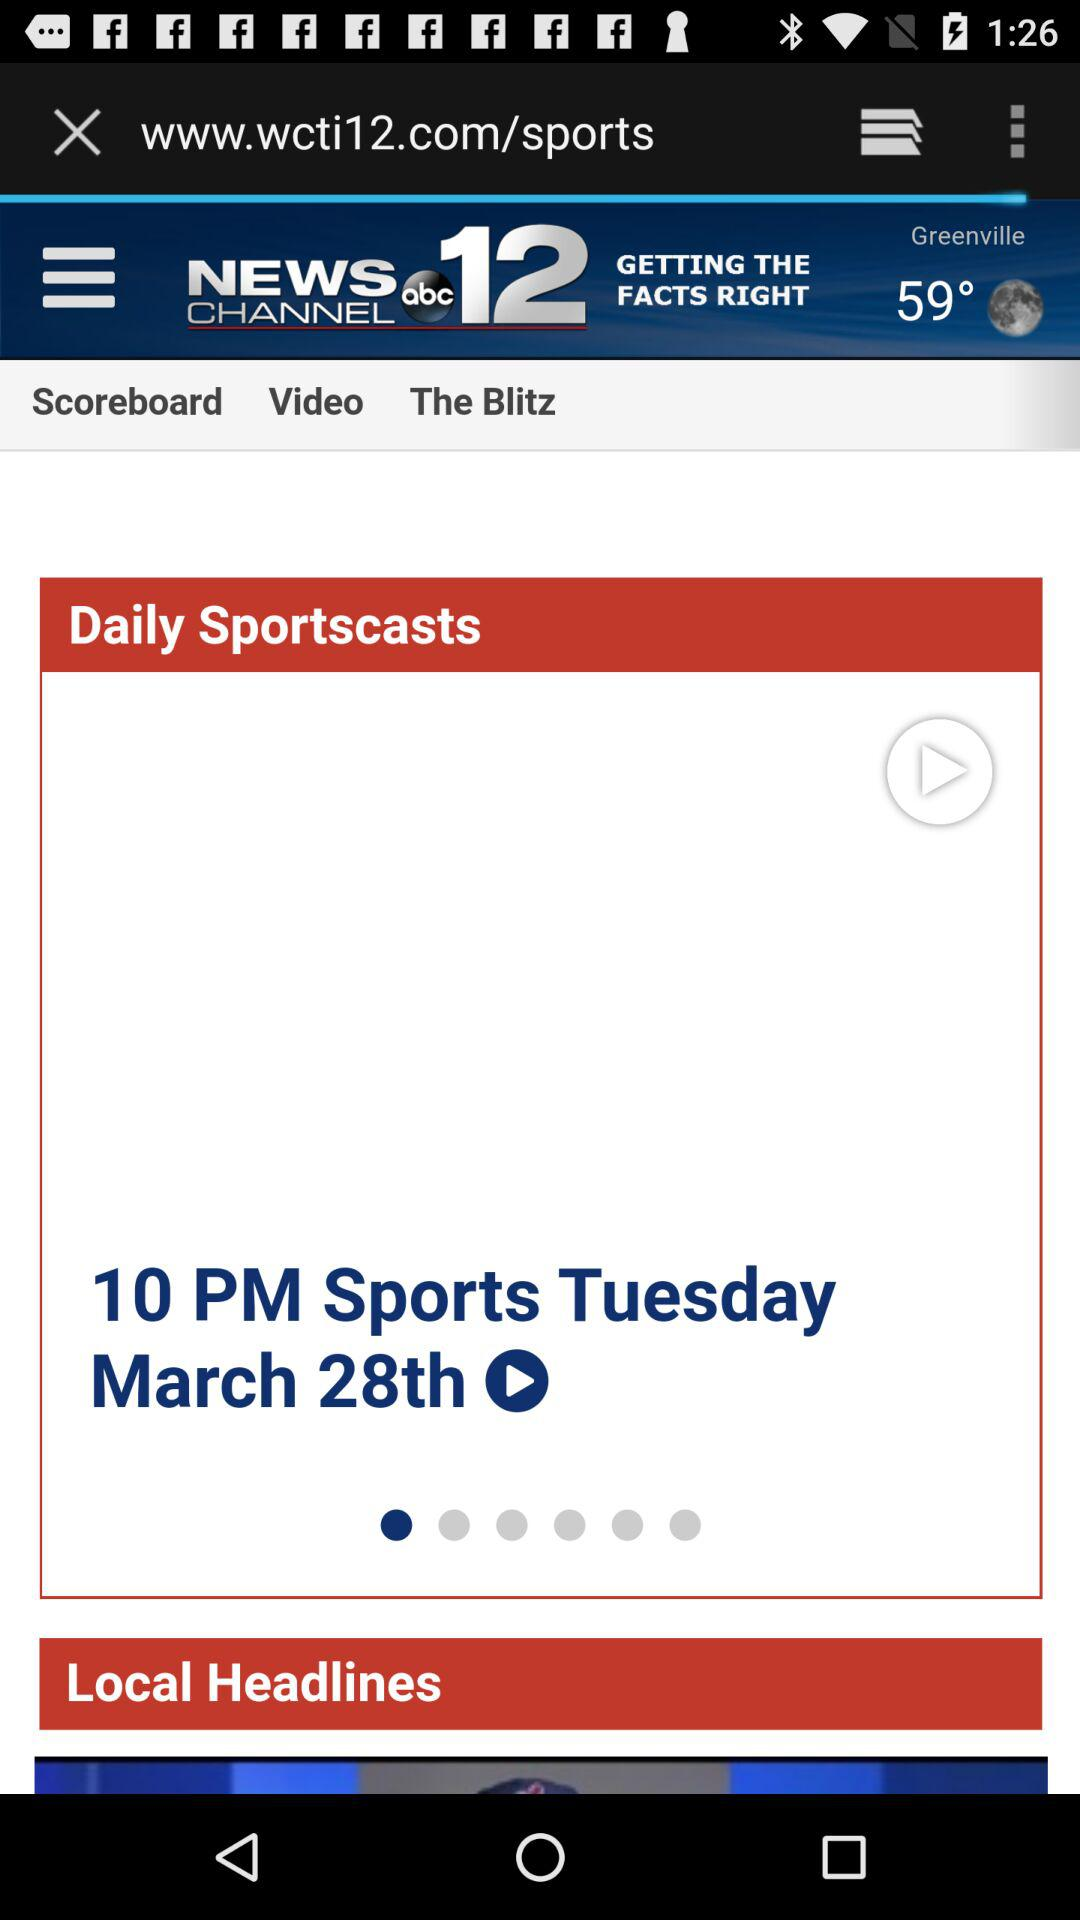What is the temperature today? The temperature is 59°. 